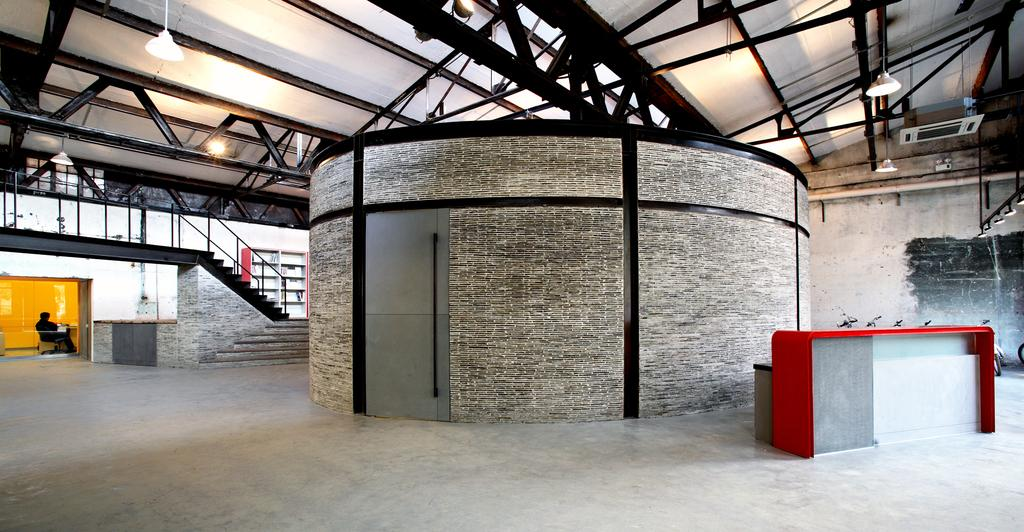What type of structure is visible in the image? There is a house in the image. Can you describe any additional structures or features in the image? There is a shed with lights in the image. Are there any people present in the image? Yes, there are persons in the image. What architectural elements can be seen in the image? There are stairs, a railing, and glass doors in the image. What color is the red color object in the image? There is a red color object in the image, but the specific shade or hue is not mentioned. What type of surface is visible in the image? There is a floor in the image. What type of barrier is present in the image? There is a wall in the image. What type of wine is being served in the morning in the image? There is no wine or indication of a morning event in the image. 